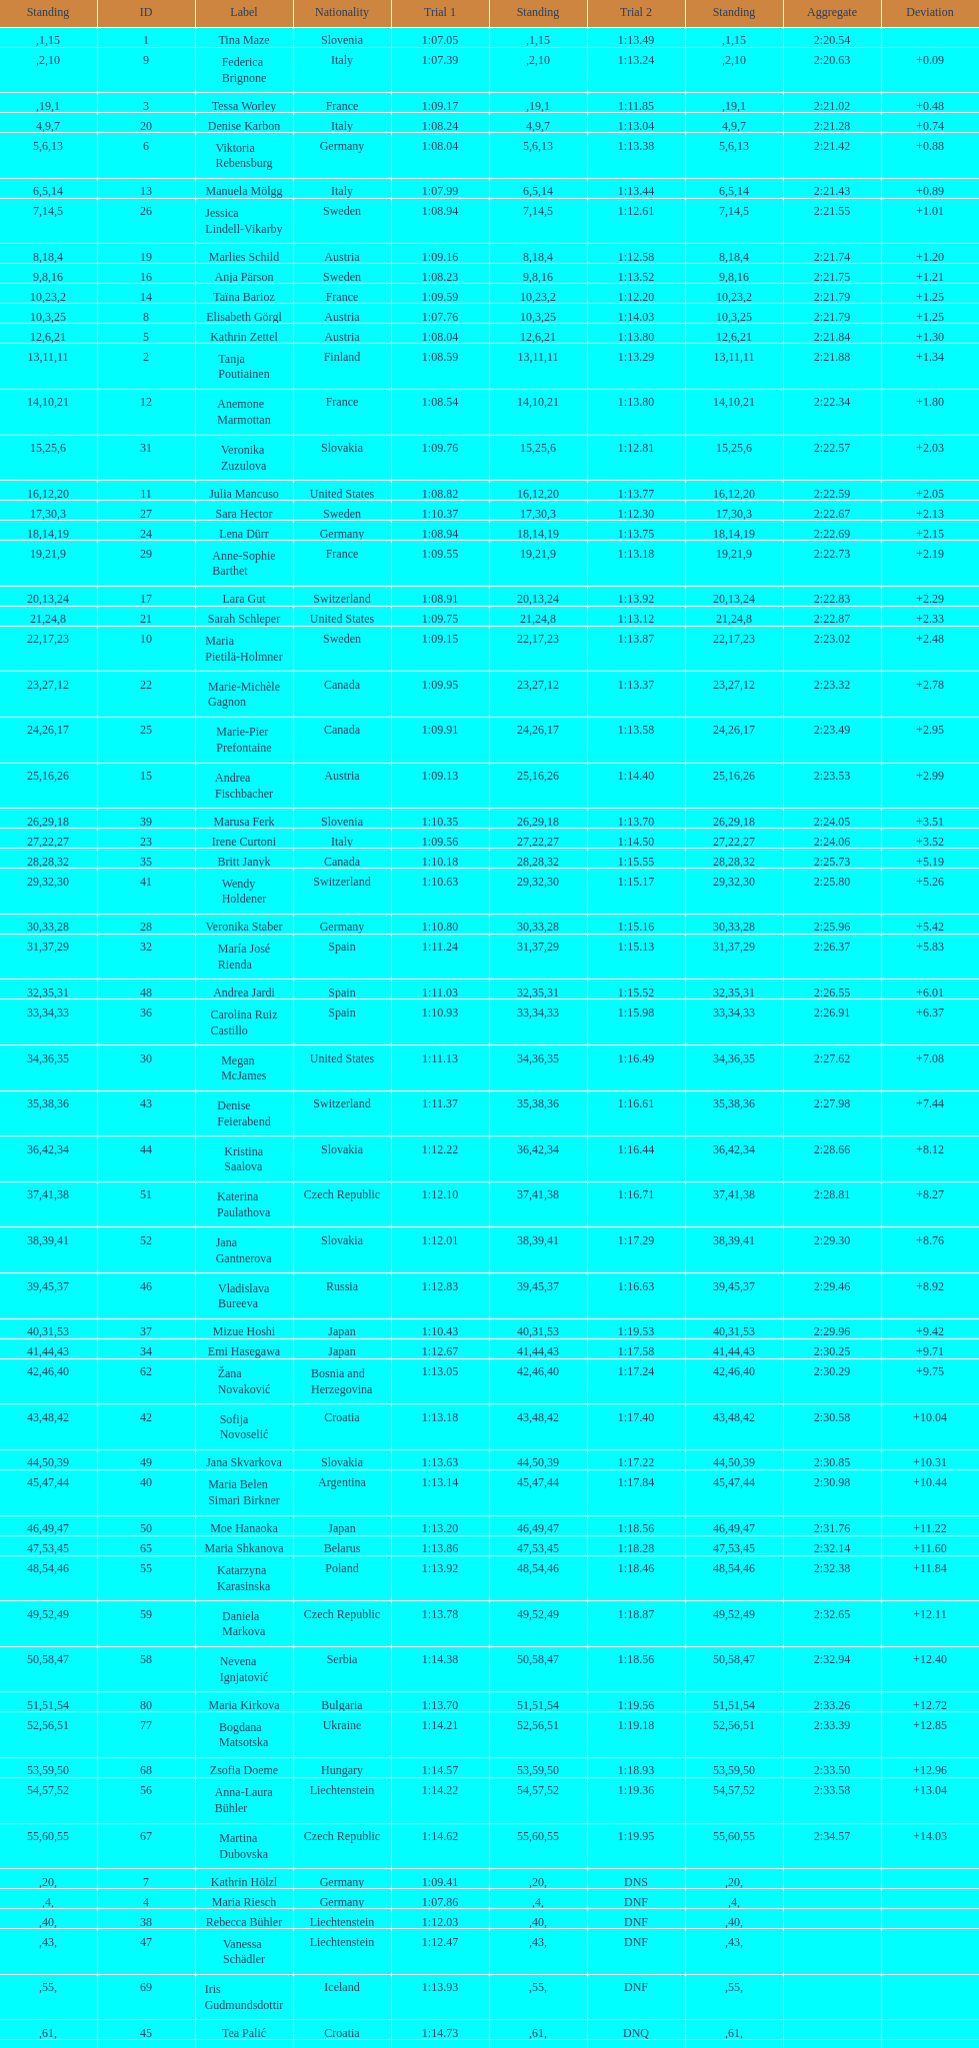What is the name before anja parson? Marlies Schild. 